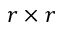<formula> <loc_0><loc_0><loc_500><loc_500>r \times r</formula> 